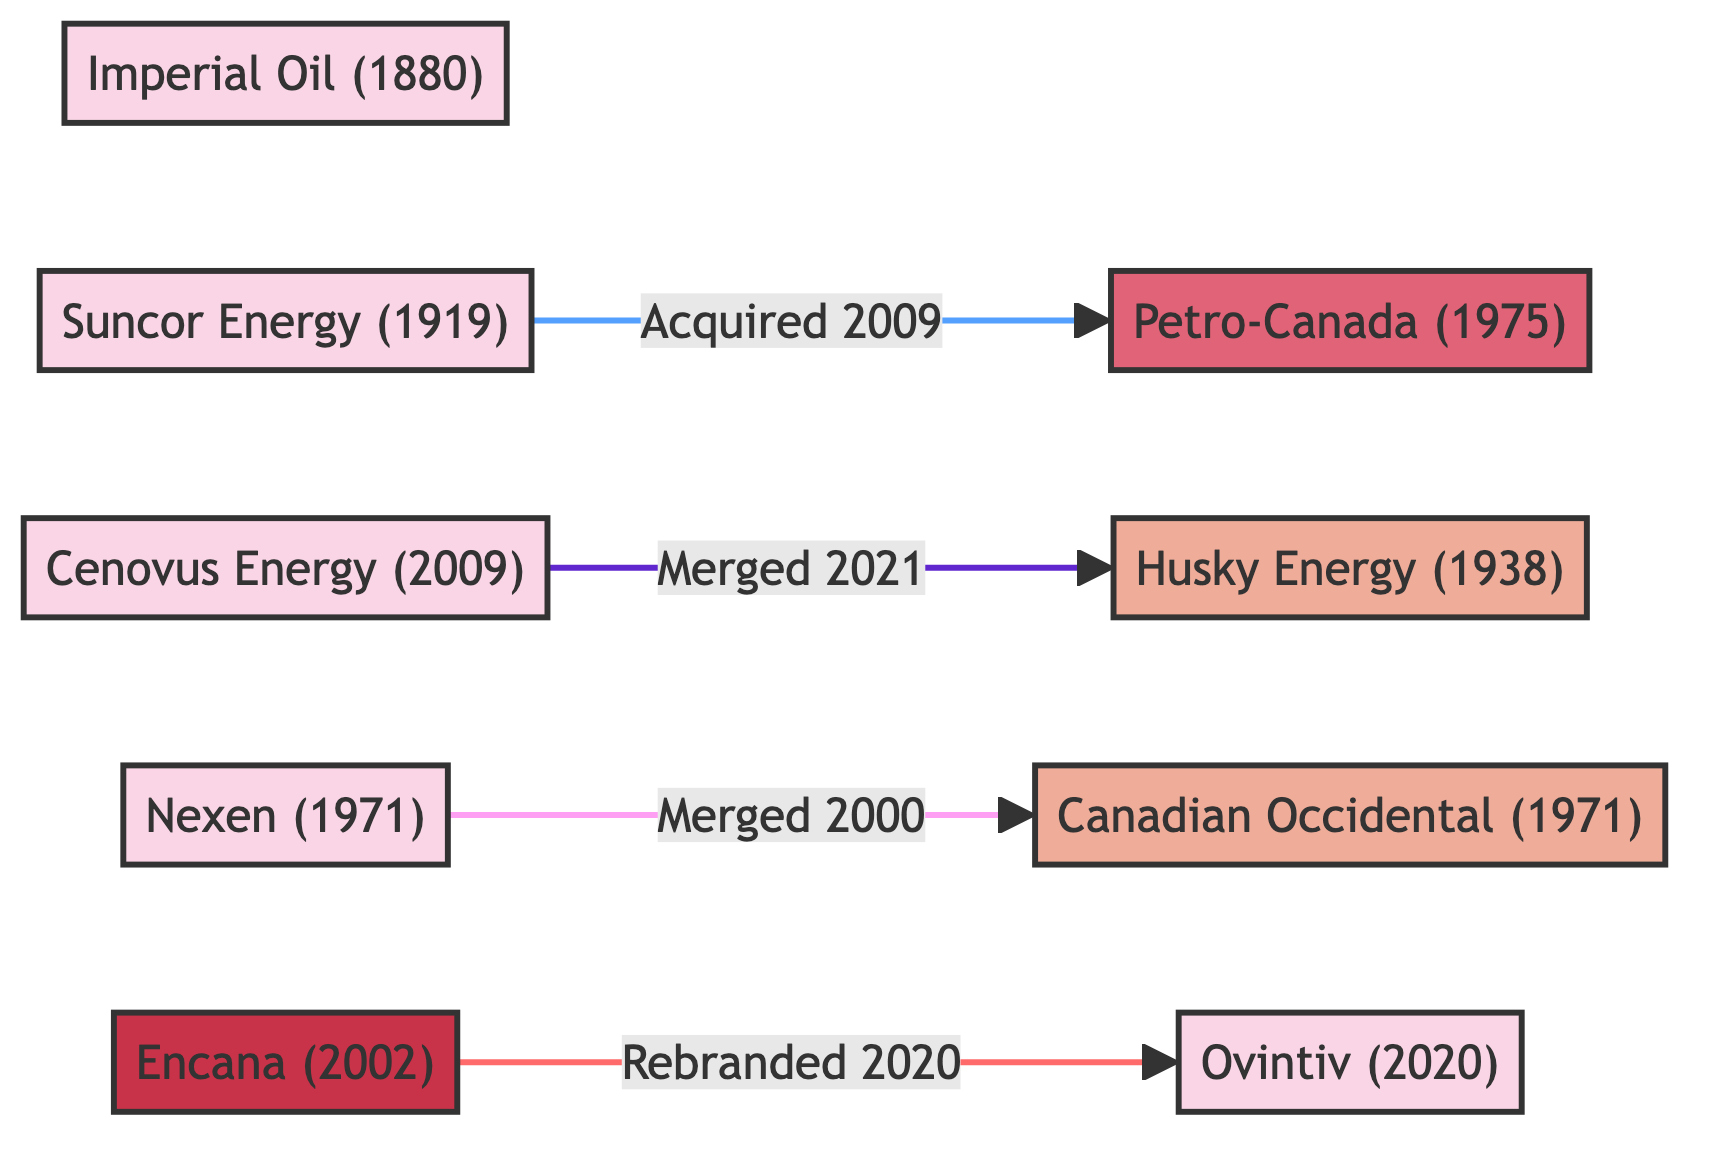What year was Imperial Oil established? The diagram indicates that Imperial Oil was established in 1880. Looking at the node for Imperial Oil, the established date is clearly listed.
Answer: 1880 How many total companies are represented in the diagram? By counting the nodes labeled as companies in the diagram, there are a total of 8 companies listed: Imperial Oil, Suncor Energy, Petro-Canada, Cenovus Energy, Canadian Occidental, Nexen, Husky Energy, and Encana.
Answer: 8 What is the relationship between Suncor Energy and Petro-Canada? The diagram shows a directional link from Suncor Energy to Petro-Canada labeled as "acquired," which indicates that Suncor Energy acquired Petro-Canada in 2009.
Answer: acquired Which company rebranded to Ovintiv? The node labeled Encana is associated with the rebranding to Ovintiv, indicated in the diagram with a link showing "rebranded." This means Encana underwent a name change to Ovintiv in 2020.
Answer: Encana What was the transaction value when Suncor Energy acquired Petro-Canada? The specifics mentioned in the diagram state that the acquisition of Petro-Canada by Suncor Energy was valued at $19.2 billion. This transaction's value is part of the details tied to the link between these two companies.
Answer: $19.2 billion How many mergers are indicated in the diagram? By examining the links in the diagram, there are two instances of mergers: Nexen merging with Canadian Occidental in 2000 and Cenovus Energy merging with Husky Energy in 2021. Counting these gives a total of 2 mergers shown.
Answer: 2 What color represents the rebranding relationship in the diagram? The rebranding relationship, as shown in the diagram, is represented by a specific color. By identifying the color associated with the link from Encana to Ovintiv, we see that it is marked in red, which signifies the rebranding relationship.
Answer: red What year did Cenovus Energy merge with Husky Energy? Looking at the link specified in the diagram, it states that Cenovus Energy merged with Husky Energy in 2021, which is clearly indicated next to the link connecting these two nodes.
Answer: 2021 